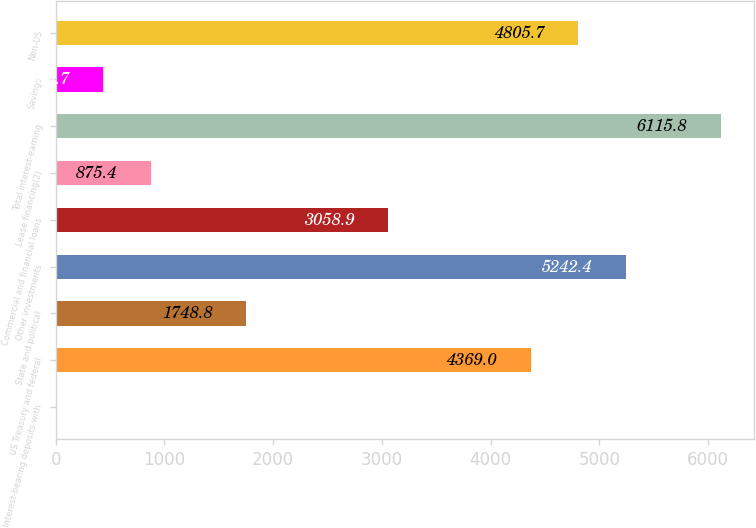Convert chart. <chart><loc_0><loc_0><loc_500><loc_500><bar_chart><fcel>Interest-bearing deposits with<fcel>US Treasury and federal<fcel>State and political<fcel>Other investments<fcel>Commercial and financial loans<fcel>Lease financing(2)<fcel>Total interest-earning<fcel>Savings<fcel>Non-US<nl><fcel>2<fcel>4369<fcel>1748.8<fcel>5242.4<fcel>3058.9<fcel>875.4<fcel>6115.8<fcel>438.7<fcel>4805.7<nl></chart> 